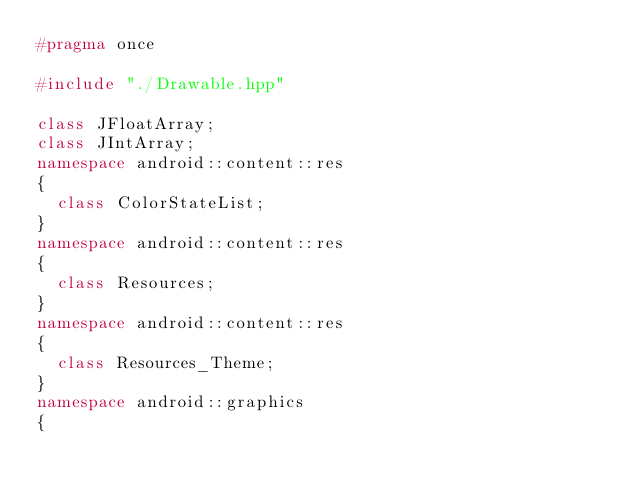Convert code to text. <code><loc_0><loc_0><loc_500><loc_500><_C++_>#pragma once

#include "./Drawable.hpp"

class JFloatArray;
class JIntArray;
namespace android::content::res
{
	class ColorStateList;
}
namespace android::content::res
{
	class Resources;
}
namespace android::content::res
{
	class Resources_Theme;
}
namespace android::graphics
{</code> 